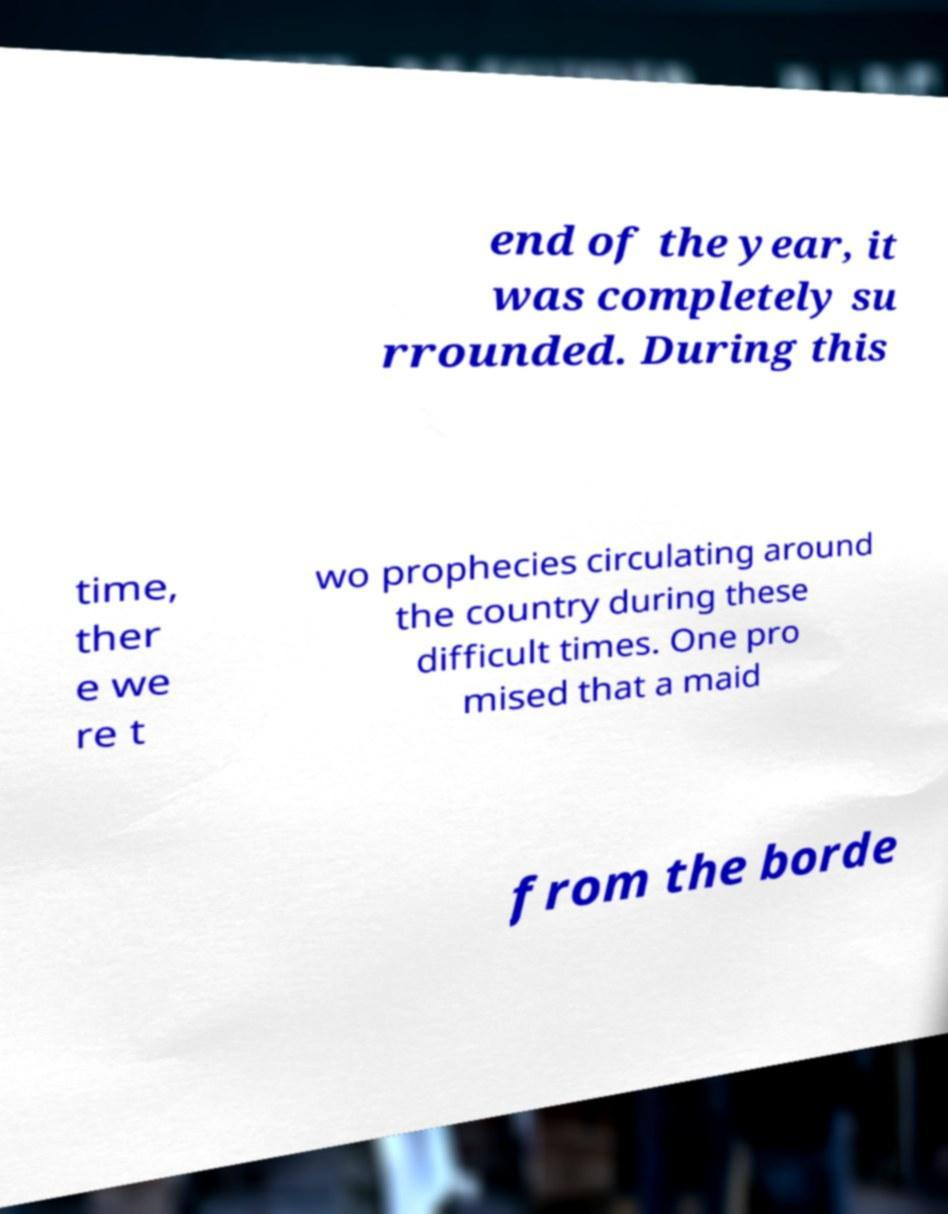Can you accurately transcribe the text from the provided image for me? end of the year, it was completely su rrounded. During this time, ther e we re t wo prophecies circulating around the country during these difficult times. One pro mised that a maid from the borde 